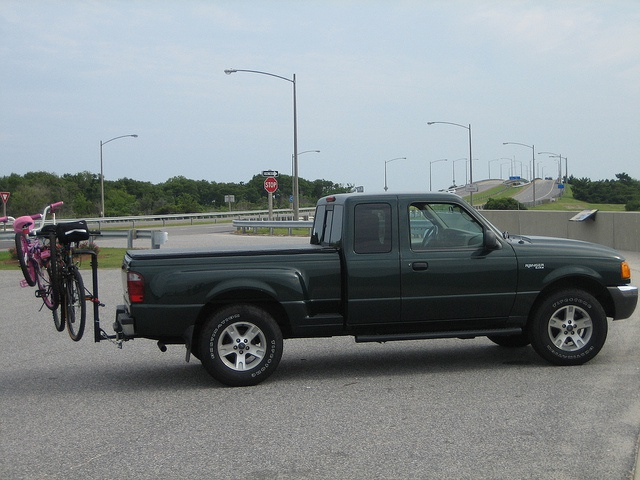Describe the objects in this image and their specific colors. I can see truck in lightgray, black, gray, purple, and darkgray tones, bicycle in lightgray, black, and gray tones, bicycle in lightgray, black, gray, purple, and darkgray tones, and stop sign in lightgray, brown, darkgray, and gray tones in this image. 